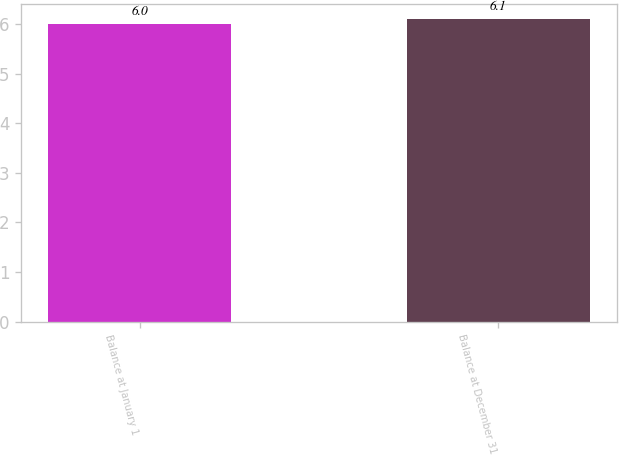Convert chart. <chart><loc_0><loc_0><loc_500><loc_500><bar_chart><fcel>Balance at January 1<fcel>Balance at December 31<nl><fcel>6<fcel>6.1<nl></chart> 